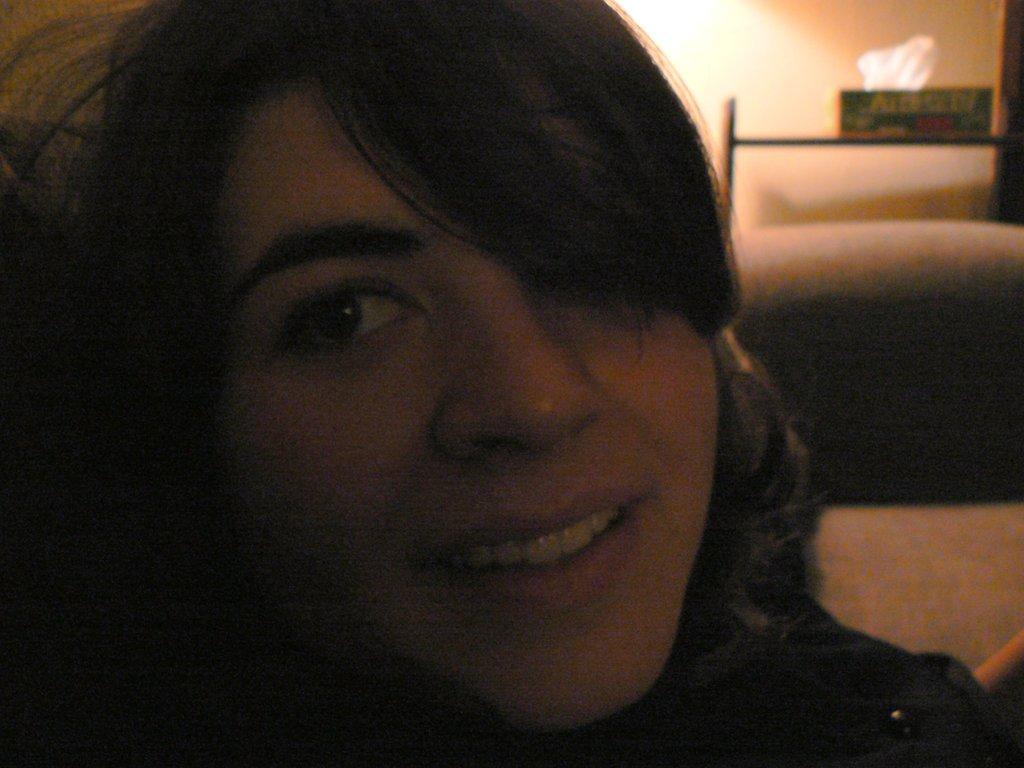Describe this image in one or two sentences. In the center of the image there is a woman's face. 